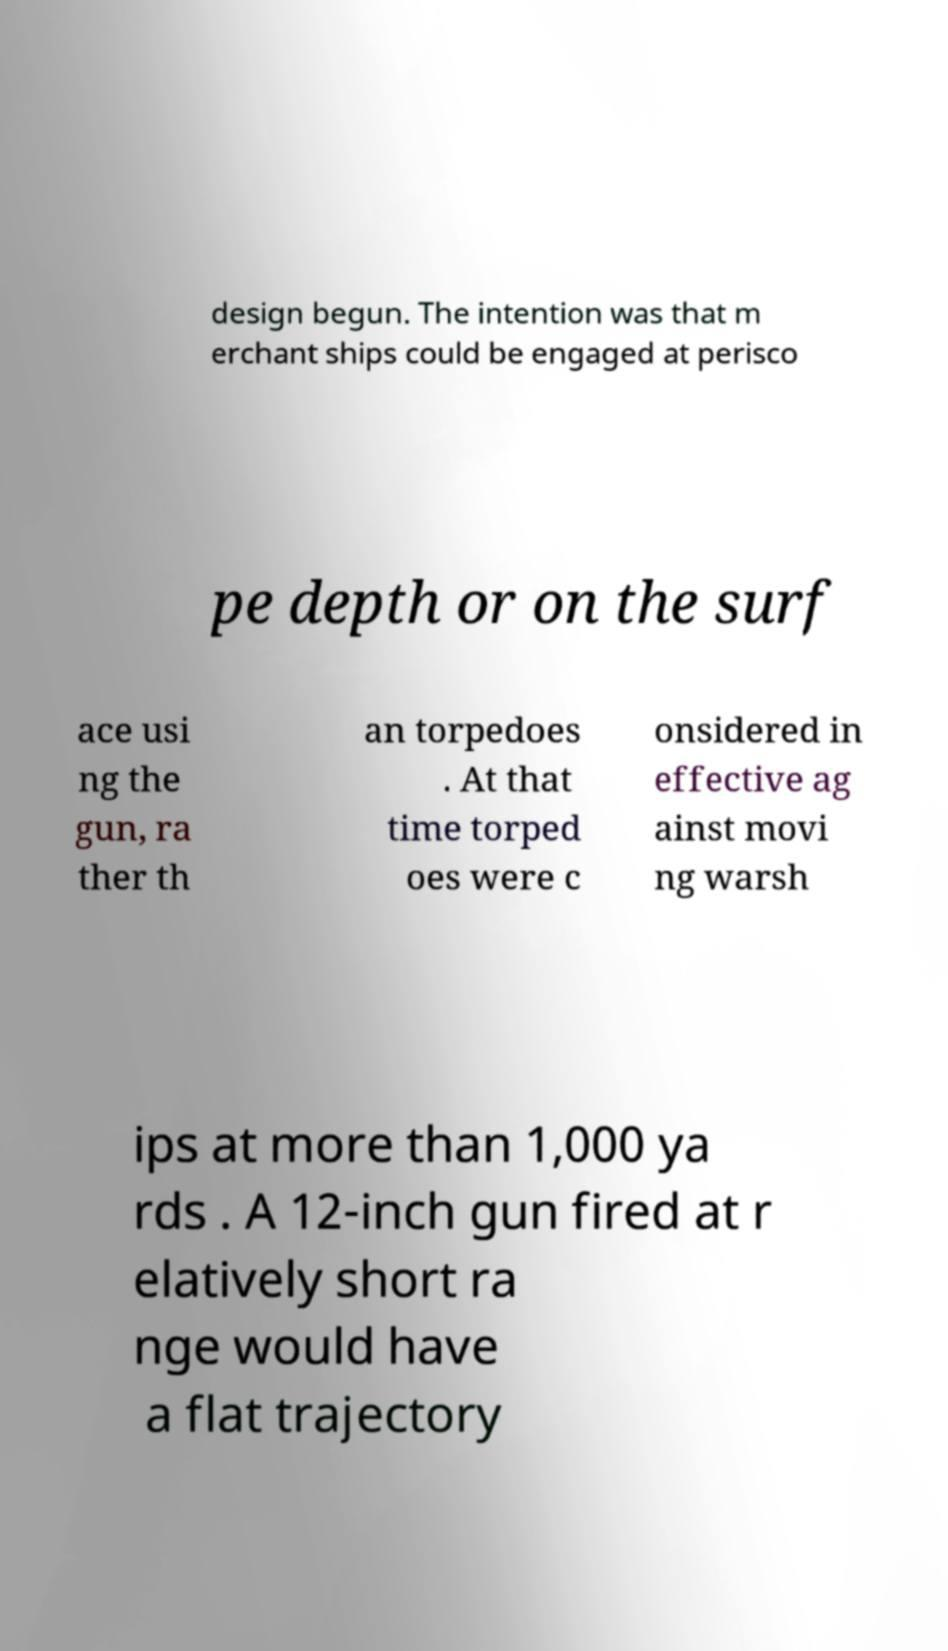I need the written content from this picture converted into text. Can you do that? design begun. The intention was that m erchant ships could be engaged at perisco pe depth or on the surf ace usi ng the gun, ra ther th an torpedoes . At that time torped oes were c onsidered in effective ag ainst movi ng warsh ips at more than 1,000 ya rds . A 12-inch gun fired at r elatively short ra nge would have a flat trajectory 